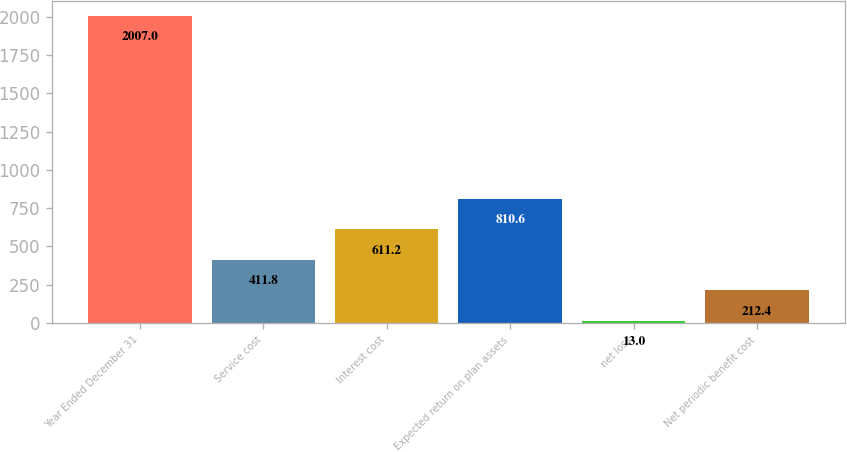Convert chart. <chart><loc_0><loc_0><loc_500><loc_500><bar_chart><fcel>Year Ended December 31<fcel>Service cost<fcel>Interest cost<fcel>Expected return on plan assets<fcel>net loss<fcel>Net periodic benefit cost<nl><fcel>2007<fcel>411.8<fcel>611.2<fcel>810.6<fcel>13<fcel>212.4<nl></chart> 